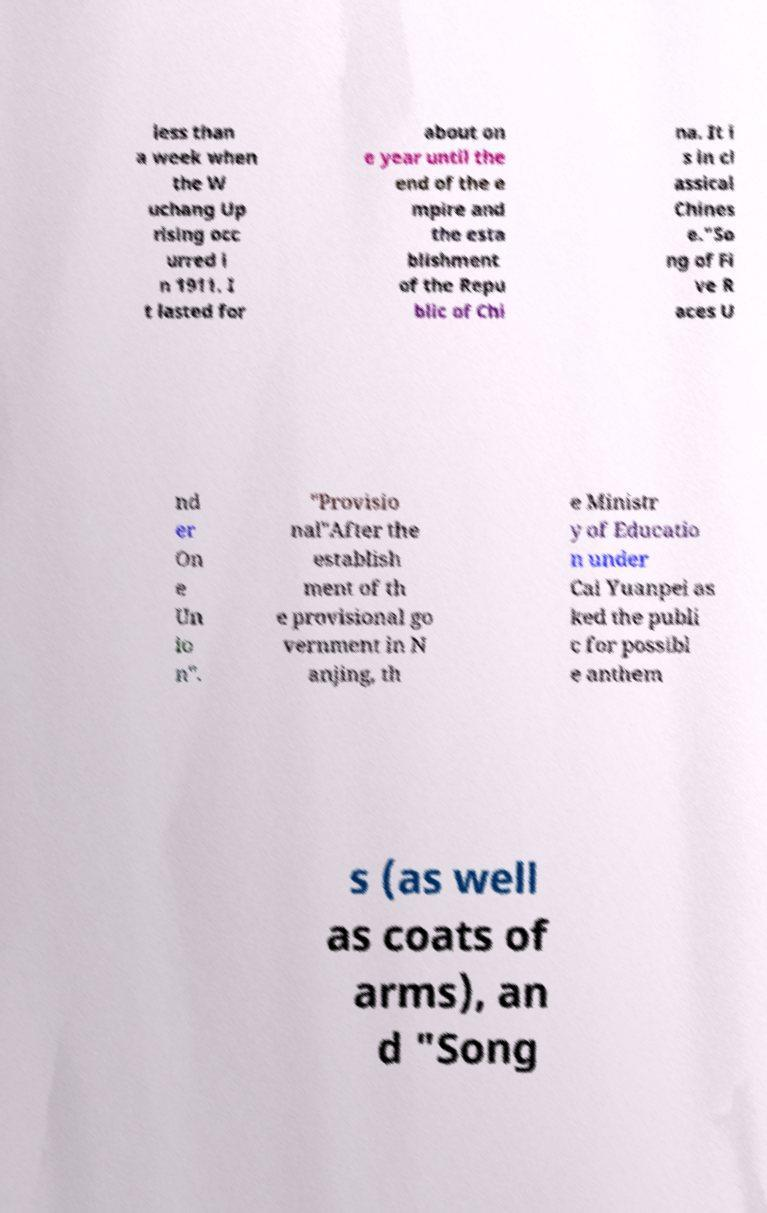Can you accurately transcribe the text from the provided image for me? less than a week when the W uchang Up rising occ urred i n 1911. I t lasted for about on e year until the end of the e mpire and the esta blishment of the Repu blic of Chi na. It i s in cl assical Chines e."So ng of Fi ve R aces U nd er On e Un io n". "Provisio nal"After the establish ment of th e provisional go vernment in N anjing, th e Ministr y of Educatio n under Cai Yuanpei as ked the publi c for possibl e anthem s (as well as coats of arms), an d "Song 